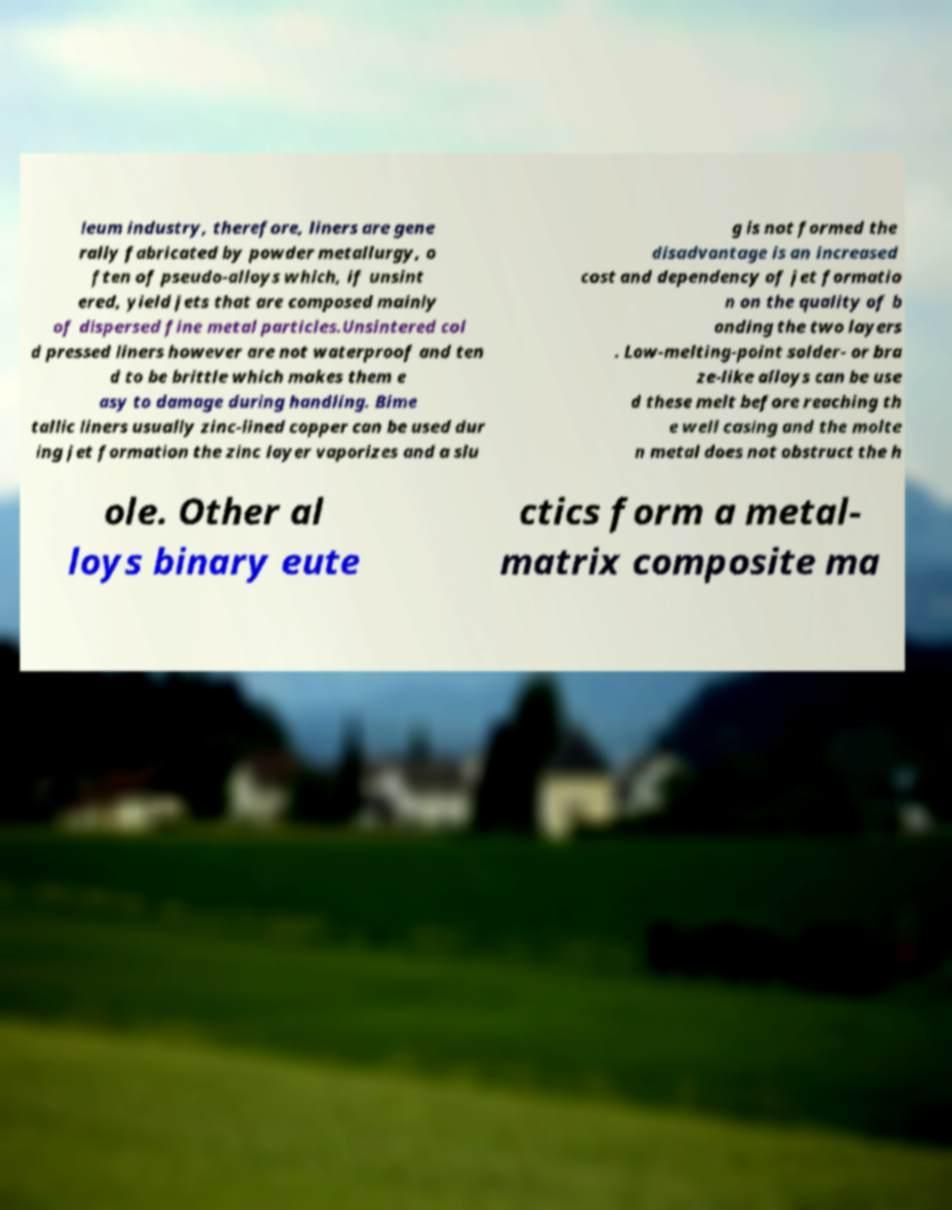Please identify and transcribe the text found in this image. leum industry, therefore, liners are gene rally fabricated by powder metallurgy, o ften of pseudo-alloys which, if unsint ered, yield jets that are composed mainly of dispersed fine metal particles.Unsintered col d pressed liners however are not waterproof and ten d to be brittle which makes them e asy to damage during handling. Bime tallic liners usually zinc-lined copper can be used dur ing jet formation the zinc layer vaporizes and a slu g is not formed the disadvantage is an increased cost and dependency of jet formatio n on the quality of b onding the two layers . Low-melting-point solder- or bra ze-like alloys can be use d these melt before reaching th e well casing and the molte n metal does not obstruct the h ole. Other al loys binary eute ctics form a metal- matrix composite ma 